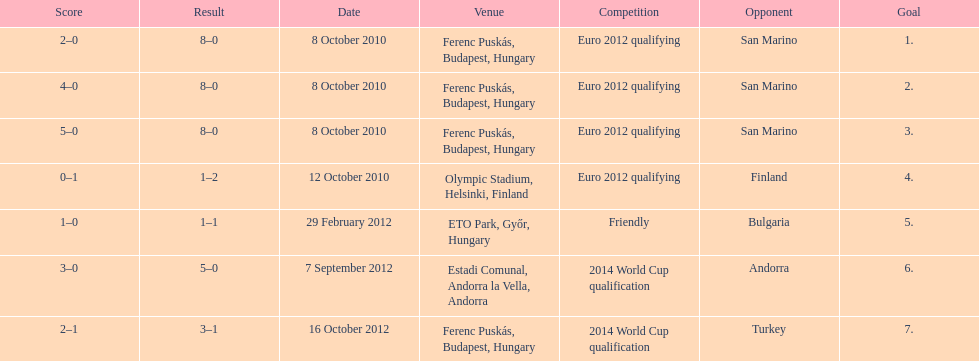What is the total number of international goals ádám szalai has made? 7. 